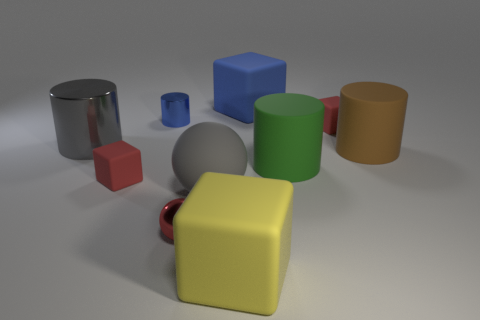There is a tiny rubber thing that is on the left side of the tiny rubber cube right of the red matte thing in front of the large gray metal thing; what shape is it?
Your answer should be very brief. Cube. What material is the thing that is the same color as the tiny shiny cylinder?
Provide a short and direct response. Rubber. Is the color of the large rubber sphere the same as the large metal cylinder?
Make the answer very short. Yes. There is a red ball right of the small blue shiny cylinder; what material is it?
Your answer should be very brief. Metal. What is the material of the gray cylinder that is the same size as the green cylinder?
Offer a very short reply. Metal. What is the big cylinder left of the small thing that is in front of the small red thing that is to the left of the small blue shiny cylinder made of?
Make the answer very short. Metal. What number of large things are gray cylinders or red metal balls?
Ensure brevity in your answer.  1. How many other things are there of the same color as the shiny ball?
Make the answer very short. 2. What number of large yellow objects are the same material as the blue cylinder?
Make the answer very short. 0. There is a rubber block left of the yellow thing; is its color the same as the tiny cylinder?
Give a very brief answer. No. 